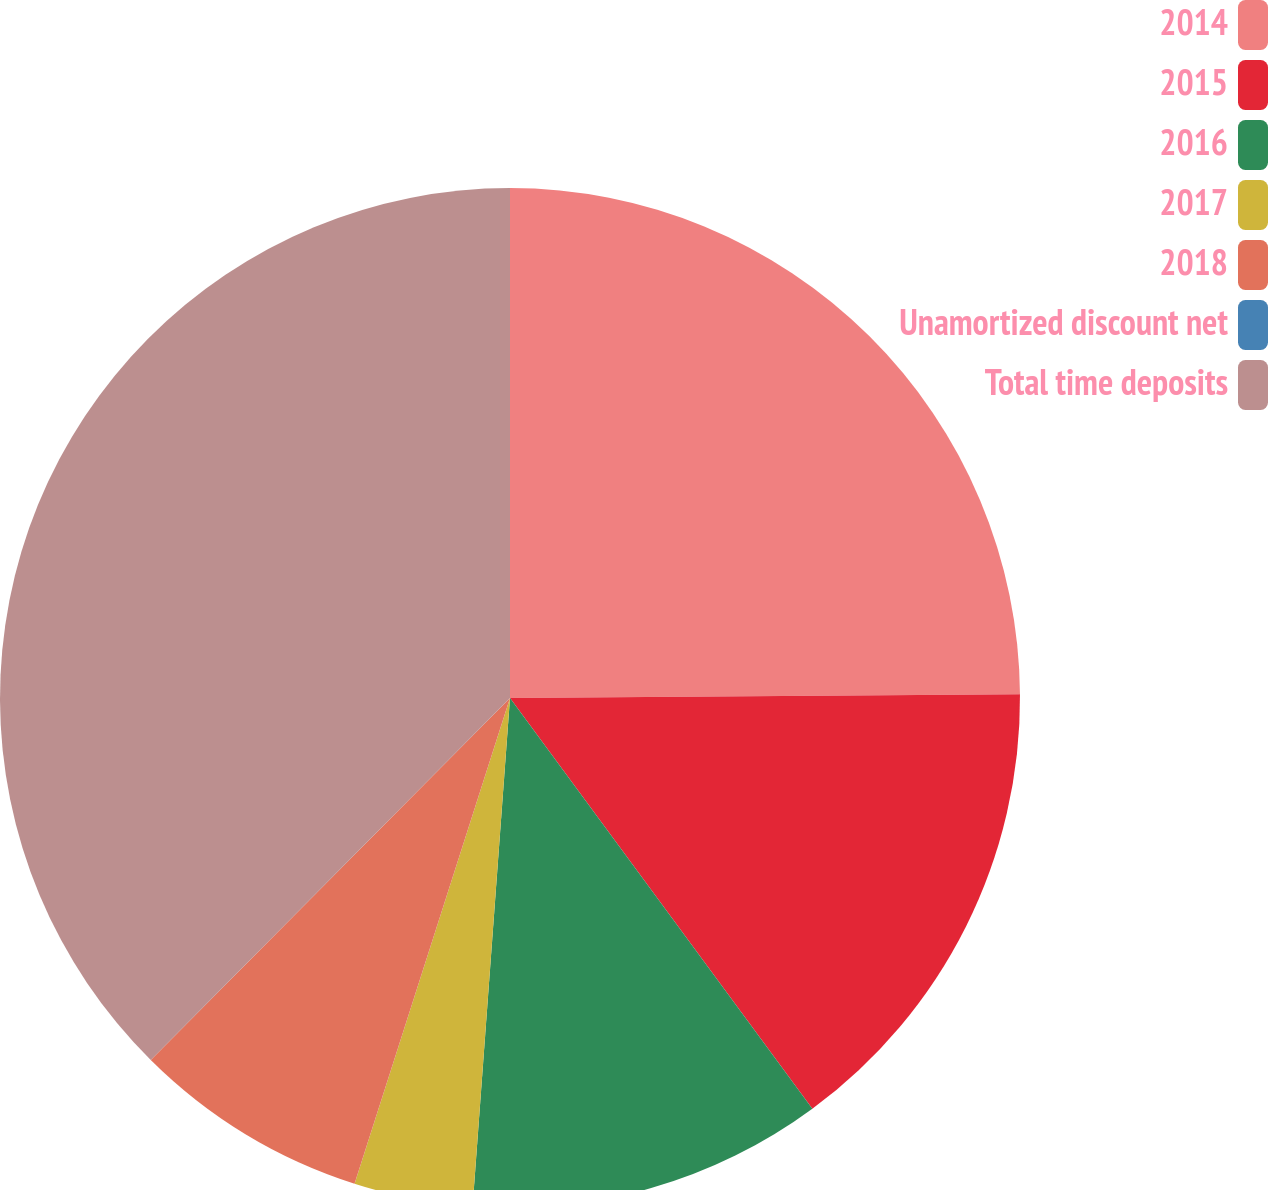Convert chart to OTSL. <chart><loc_0><loc_0><loc_500><loc_500><pie_chart><fcel>2014<fcel>2015<fcel>2016<fcel>2017<fcel>2018<fcel>Unamortized discount net<fcel>Total time deposits<nl><fcel>24.88%<fcel>15.02%<fcel>11.27%<fcel>3.76%<fcel>7.51%<fcel>0.0%<fcel>37.56%<nl></chart> 